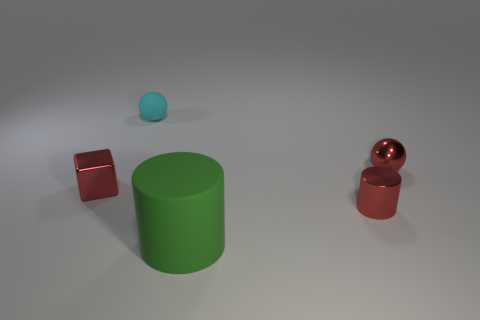Add 3 large red matte blocks. How many objects exist? 8 Subtract all blocks. How many objects are left? 4 Subtract all purple matte cylinders. Subtract all small rubber things. How many objects are left? 4 Add 1 small shiny spheres. How many small shiny spheres are left? 2 Add 3 red shiny objects. How many red shiny objects exist? 6 Subtract 0 brown spheres. How many objects are left? 5 